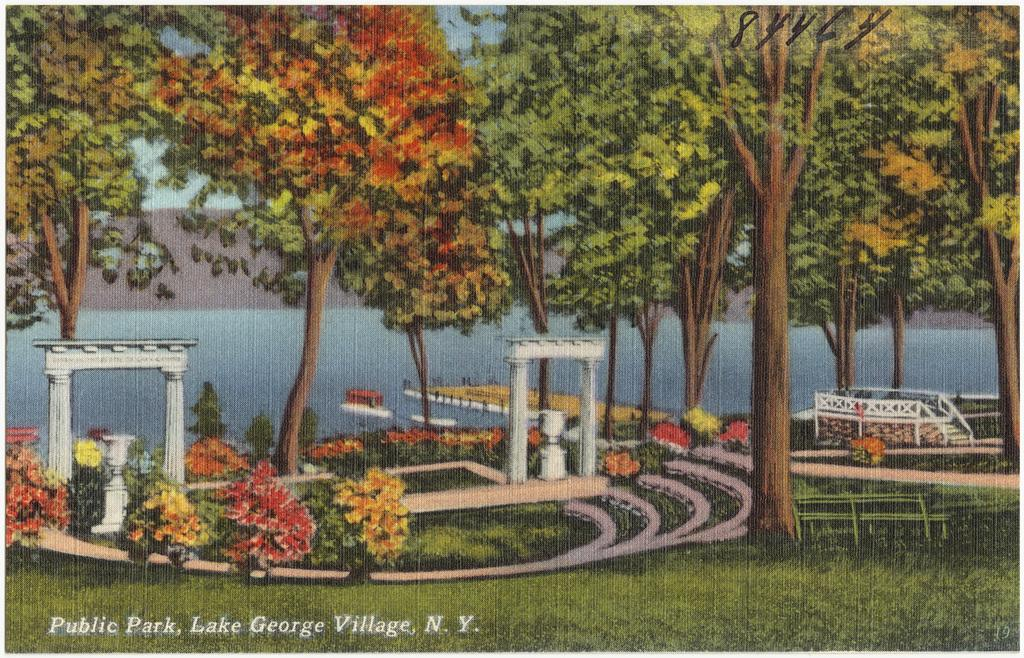What type of location is depicted in the image? There is a park in the image. What features can be found in the park? There are stairs, plants, grass, trees, and a lake in the park. What is the condition of the sky in the image? The sky is clear in the image. What type of list can be seen hanging from the tree in the image? There is no list present in the image; it features a park with various natural elements and a lake in the background. Can you tell me how many sheep are grazing in the grass in the image? There are no sheep present in the image; it depicts a park with trees, plants, and a lake in the background. 